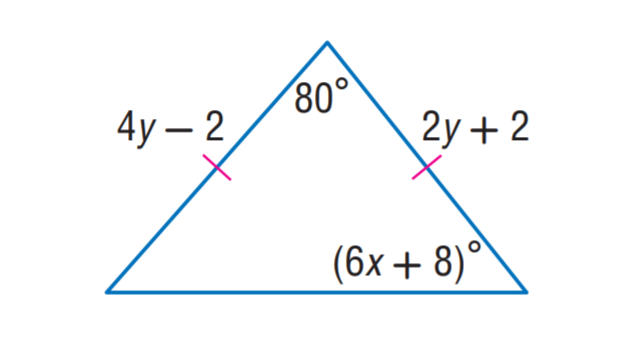Answer the mathemtical geometry problem and directly provide the correct option letter.
Question: Find x.
Choices: A: 5 B: 7 C: 8 D: 10 B 